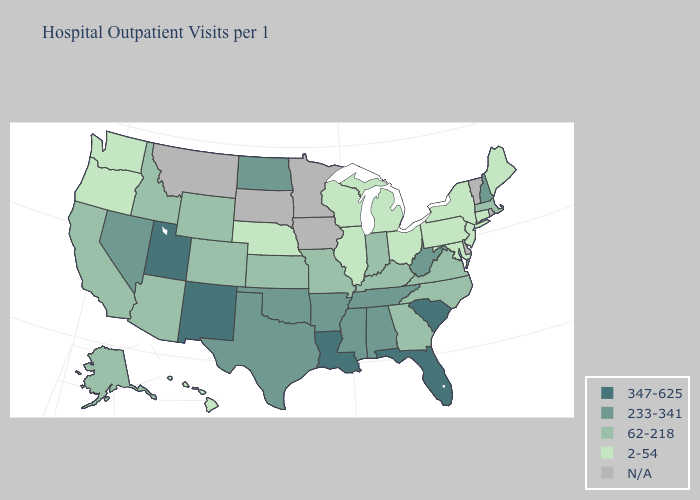Which states have the lowest value in the Northeast?
Short answer required. Connecticut, Maine, New Jersey, New York, Pennsylvania. Name the states that have a value in the range 62-218?
Give a very brief answer. Alaska, Arizona, California, Colorado, Georgia, Idaho, Indiana, Kansas, Kentucky, Massachusetts, Missouri, North Carolina, Virginia, Wyoming. Name the states that have a value in the range N/A?
Concise answer only. Delaware, Iowa, Minnesota, Montana, Rhode Island, South Dakota, Vermont. Name the states that have a value in the range 233-341?
Concise answer only. Alabama, Arkansas, Mississippi, Nevada, New Hampshire, North Dakota, Oklahoma, Tennessee, Texas, West Virginia. How many symbols are there in the legend?
Be succinct. 5. Among the states that border Utah , which have the lowest value?
Concise answer only. Arizona, Colorado, Idaho, Wyoming. Does New York have the highest value in the Northeast?
Quick response, please. No. Is the legend a continuous bar?
Keep it brief. No. Among the states that border Nebraska , which have the highest value?
Give a very brief answer. Colorado, Kansas, Missouri, Wyoming. Is the legend a continuous bar?
Concise answer only. No. Among the states that border Ohio , does Kentucky have the lowest value?
Keep it brief. No. Among the states that border New Mexico , which have the lowest value?
Quick response, please. Arizona, Colorado. Which states have the lowest value in the USA?
Give a very brief answer. Connecticut, Hawaii, Illinois, Maine, Maryland, Michigan, Nebraska, New Jersey, New York, Ohio, Oregon, Pennsylvania, Washington, Wisconsin. Does the first symbol in the legend represent the smallest category?
Short answer required. No. Name the states that have a value in the range 62-218?
Be succinct. Alaska, Arizona, California, Colorado, Georgia, Idaho, Indiana, Kansas, Kentucky, Massachusetts, Missouri, North Carolina, Virginia, Wyoming. 